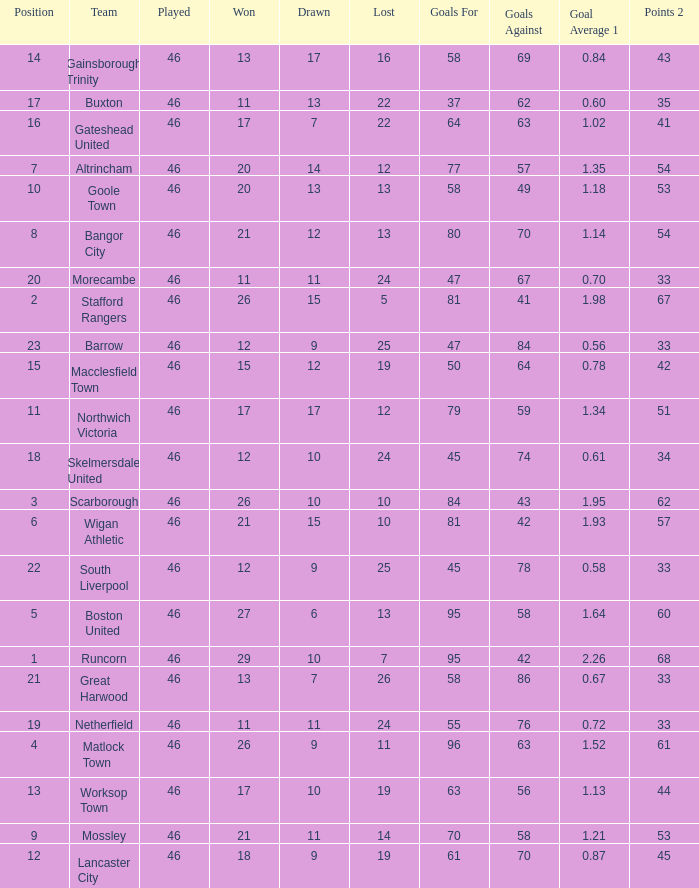Which team had goal averages of 1.34? Northwich Victoria. 